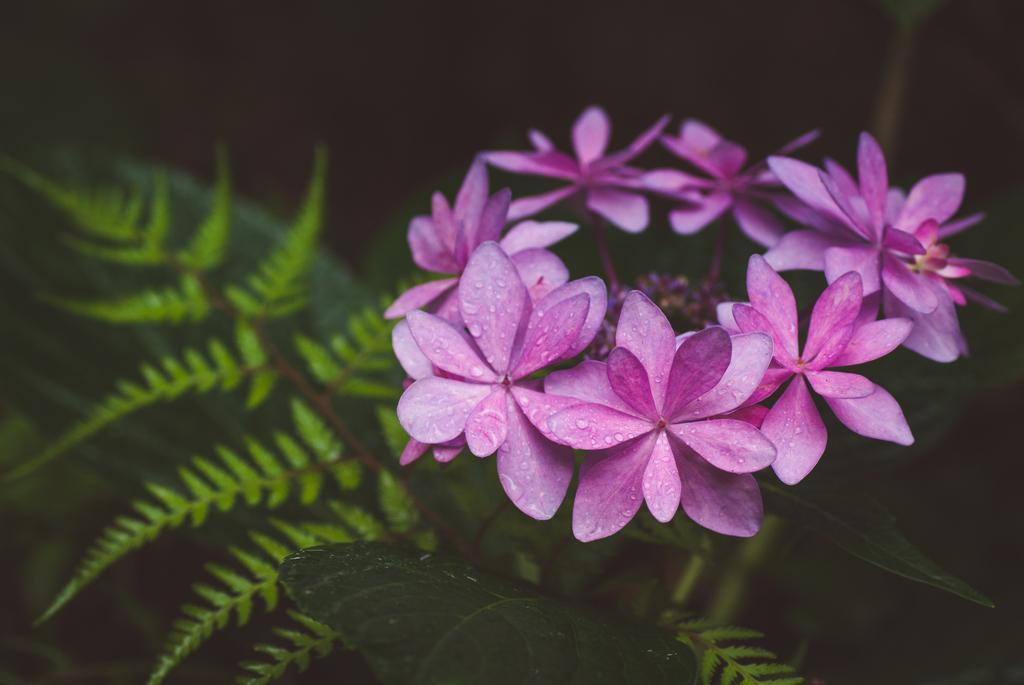How would you summarize this image in a sentence or two? This image consists of flowers which are pink in colour in the front and there are leaves. 